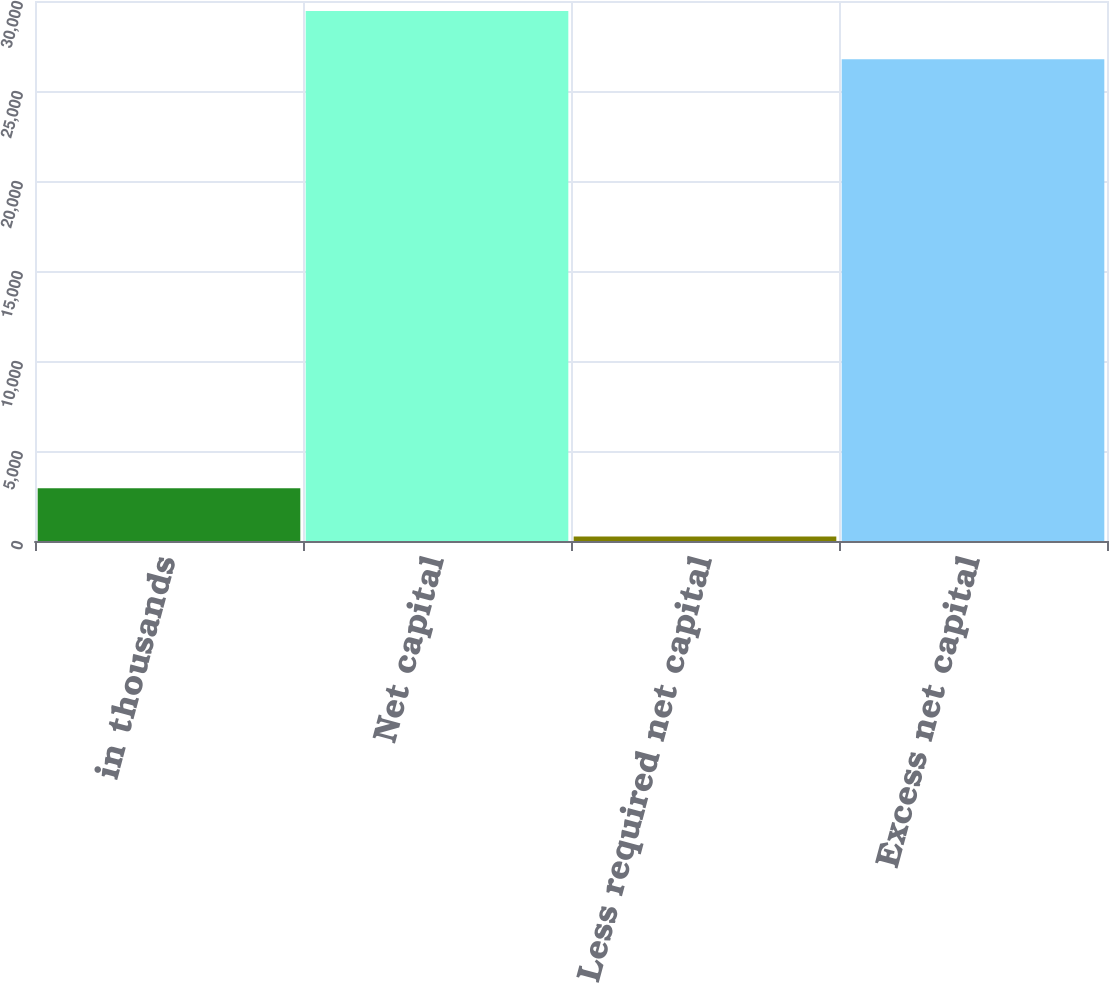Convert chart. <chart><loc_0><loc_0><loc_500><loc_500><bar_chart><fcel>in thousands<fcel>Net capital<fcel>Less required net capital<fcel>Excess net capital<nl><fcel>2926.3<fcel>29439.3<fcel>250<fcel>26763<nl></chart> 